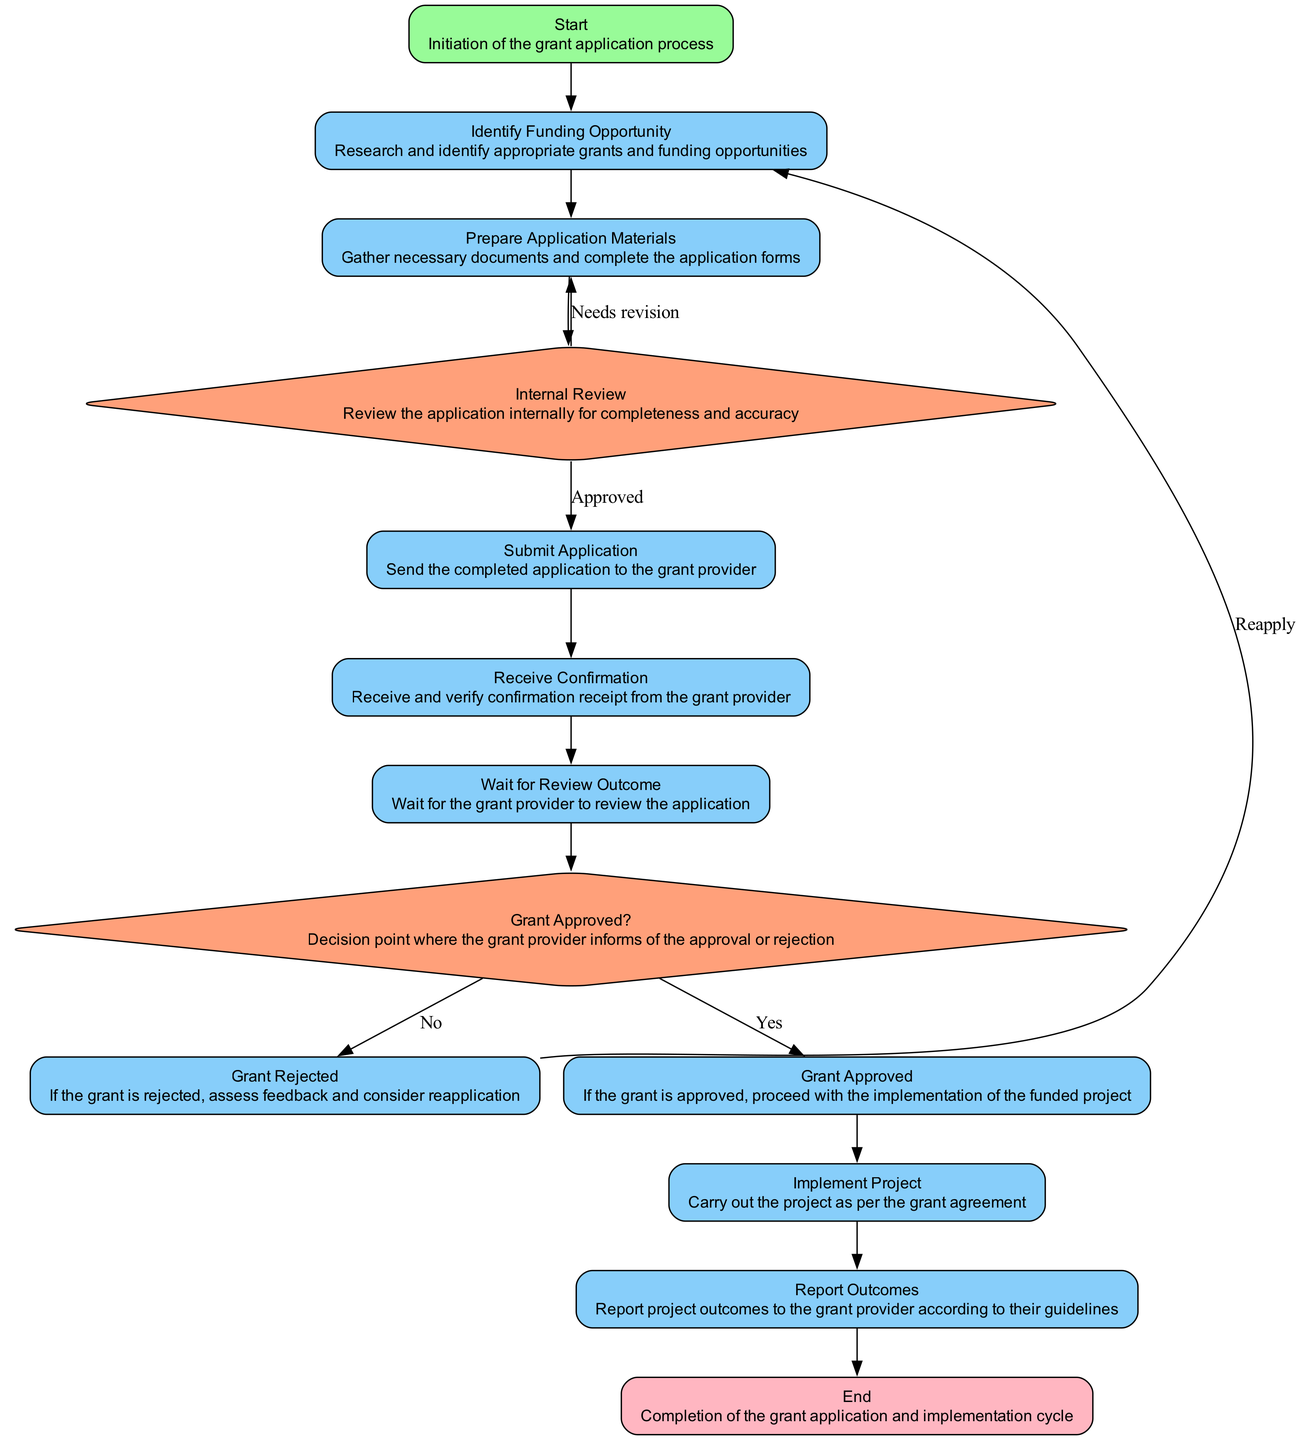What is the first step in the workflow? The workflow begins with the "Start" node, which indicates the initiation of the grant application process.
Answer: Start How many processes are there in the workflow? Counting all the nodes labeled as "process," there are 8: Identify Funding Opportunity, Prepare Application Materials, Submit Application, Receive Confirmation, Wait for Review Outcome, Grant Rejected, Grant Approved, and Implement Project.
Answer: 8 What is the outcome if the grant is approved? If the grant is approved, the workflow leads to "Implement Project," indicating that the organization should carry out the project according to the grant agreement.
Answer: Implement Project What happens after the "Internal Review" if the application is approved? If the application is approved, it leads directly to "Submit Application," indicating that the necessary documents can be sent to the grant provider for processing.
Answer: Submit Application What decision is made after waiting for the review outcome? After waiting for the review outcome, the decision relates to whether the grant is "Approved?" or "Rejected?", which provides the next steps based on that decision.
Answer: Grant Approved? If a grant is rejected, which process step is taken next? If the grant is rejected, the flow directs on to "Grant Rejected," where the organization assesses feedback and considers reapplication.
Answer: Grant Rejected What color represents decision nodes in the diagram? Decision nodes are represented in light salmon color according to the color coding defined in the diagram for different types of nodes.
Answer: Light salmon How does one proceed if the application needs revision during the internal review? If the application requires revision during the internal review, the flow loops back to "Prepare Application Materials," indicating that necessary changes should be made before resubmission.
Answer: Prepare Application Materials 